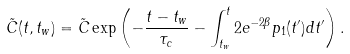<formula> <loc_0><loc_0><loc_500><loc_500>\tilde { C } ( t , t _ { w } ) = \tilde { C } \exp \left ( - \frac { t - t _ { w } } { \tau _ { c } } - \int _ { t _ { w } } ^ { t } 2 e ^ { - 2 \beta } p _ { 1 } ( t ^ { \prime } ) d t ^ { \prime } \right ) .</formula> 